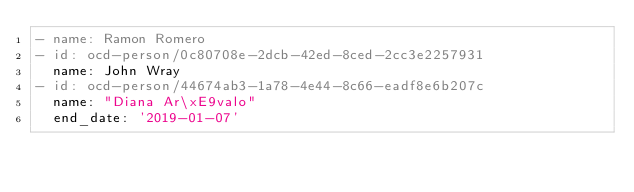Convert code to text. <code><loc_0><loc_0><loc_500><loc_500><_YAML_>- name: Ramon Romero
- id: ocd-person/0c80708e-2dcb-42ed-8ced-2cc3e2257931
  name: John Wray
- id: ocd-person/44674ab3-1a78-4e44-8c66-eadf8e6b207c
  name: "Diana Ar\xE9valo"
  end_date: '2019-01-07'
</code> 